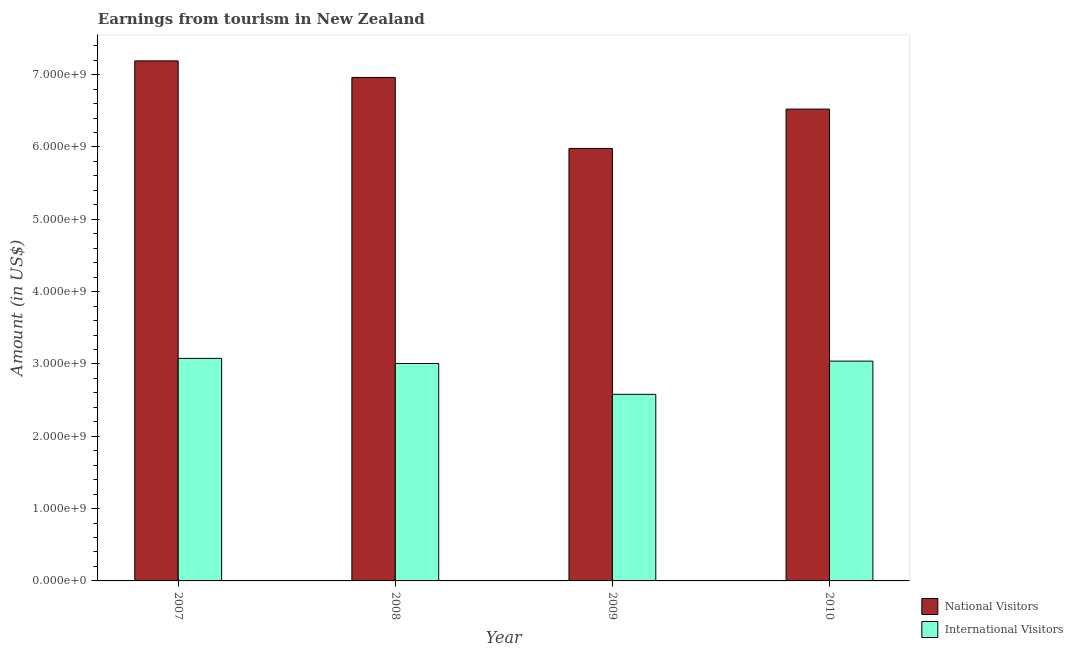How many different coloured bars are there?
Give a very brief answer. 2. Are the number of bars per tick equal to the number of legend labels?
Your answer should be very brief. Yes. How many bars are there on the 2nd tick from the left?
Keep it short and to the point. 2. How many bars are there on the 2nd tick from the right?
Your answer should be compact. 2. In how many cases, is the number of bars for a given year not equal to the number of legend labels?
Provide a short and direct response. 0. What is the amount earned from national visitors in 2010?
Ensure brevity in your answer.  6.52e+09. Across all years, what is the maximum amount earned from international visitors?
Your answer should be very brief. 3.08e+09. Across all years, what is the minimum amount earned from national visitors?
Your answer should be very brief. 5.98e+09. In which year was the amount earned from international visitors maximum?
Your answer should be very brief. 2007. What is the total amount earned from national visitors in the graph?
Keep it short and to the point. 2.67e+1. What is the difference between the amount earned from national visitors in 2008 and that in 2009?
Your answer should be very brief. 9.82e+08. What is the difference between the amount earned from national visitors in 2010 and the amount earned from international visitors in 2007?
Keep it short and to the point. -6.67e+08. What is the average amount earned from international visitors per year?
Make the answer very short. 2.93e+09. What is the ratio of the amount earned from international visitors in 2008 to that in 2010?
Make the answer very short. 0.99. Is the amount earned from international visitors in 2008 less than that in 2009?
Give a very brief answer. No. What is the difference between the highest and the second highest amount earned from international visitors?
Keep it short and to the point. 3.80e+07. What is the difference between the highest and the lowest amount earned from national visitors?
Provide a succinct answer. 1.21e+09. In how many years, is the amount earned from international visitors greater than the average amount earned from international visitors taken over all years?
Keep it short and to the point. 3. Is the sum of the amount earned from national visitors in 2008 and 2010 greater than the maximum amount earned from international visitors across all years?
Make the answer very short. Yes. What does the 2nd bar from the left in 2008 represents?
Your answer should be compact. International Visitors. What does the 2nd bar from the right in 2010 represents?
Offer a very short reply. National Visitors. How many bars are there?
Your answer should be very brief. 8. Are all the bars in the graph horizontal?
Provide a succinct answer. No. How many years are there in the graph?
Your answer should be very brief. 4. What is the difference between two consecutive major ticks on the Y-axis?
Offer a terse response. 1.00e+09. Does the graph contain any zero values?
Your response must be concise. No. Does the graph contain grids?
Give a very brief answer. No. How many legend labels are there?
Give a very brief answer. 2. What is the title of the graph?
Provide a short and direct response. Earnings from tourism in New Zealand. What is the label or title of the Y-axis?
Your answer should be compact. Amount (in US$). What is the Amount (in US$) of National Visitors in 2007?
Provide a short and direct response. 7.19e+09. What is the Amount (in US$) of International Visitors in 2007?
Provide a short and direct response. 3.08e+09. What is the Amount (in US$) of National Visitors in 2008?
Offer a very short reply. 6.96e+09. What is the Amount (in US$) in International Visitors in 2008?
Offer a very short reply. 3.01e+09. What is the Amount (in US$) of National Visitors in 2009?
Your answer should be compact. 5.98e+09. What is the Amount (in US$) in International Visitors in 2009?
Offer a terse response. 2.58e+09. What is the Amount (in US$) of National Visitors in 2010?
Make the answer very short. 6.52e+09. What is the Amount (in US$) of International Visitors in 2010?
Offer a very short reply. 3.04e+09. Across all years, what is the maximum Amount (in US$) of National Visitors?
Your answer should be very brief. 7.19e+09. Across all years, what is the maximum Amount (in US$) in International Visitors?
Provide a succinct answer. 3.08e+09. Across all years, what is the minimum Amount (in US$) of National Visitors?
Keep it short and to the point. 5.98e+09. Across all years, what is the minimum Amount (in US$) of International Visitors?
Your response must be concise. 2.58e+09. What is the total Amount (in US$) in National Visitors in the graph?
Your response must be concise. 2.67e+1. What is the total Amount (in US$) in International Visitors in the graph?
Offer a terse response. 1.17e+1. What is the difference between the Amount (in US$) in National Visitors in 2007 and that in 2008?
Your answer should be compact. 2.29e+08. What is the difference between the Amount (in US$) of International Visitors in 2007 and that in 2008?
Ensure brevity in your answer.  7.10e+07. What is the difference between the Amount (in US$) in National Visitors in 2007 and that in 2009?
Offer a terse response. 1.21e+09. What is the difference between the Amount (in US$) of International Visitors in 2007 and that in 2009?
Provide a succinct answer. 4.97e+08. What is the difference between the Amount (in US$) in National Visitors in 2007 and that in 2010?
Provide a succinct answer. 6.67e+08. What is the difference between the Amount (in US$) in International Visitors in 2007 and that in 2010?
Keep it short and to the point. 3.80e+07. What is the difference between the Amount (in US$) of National Visitors in 2008 and that in 2009?
Make the answer very short. 9.82e+08. What is the difference between the Amount (in US$) in International Visitors in 2008 and that in 2009?
Offer a very short reply. 4.26e+08. What is the difference between the Amount (in US$) in National Visitors in 2008 and that in 2010?
Offer a terse response. 4.38e+08. What is the difference between the Amount (in US$) of International Visitors in 2008 and that in 2010?
Your answer should be compact. -3.30e+07. What is the difference between the Amount (in US$) of National Visitors in 2009 and that in 2010?
Ensure brevity in your answer.  -5.44e+08. What is the difference between the Amount (in US$) in International Visitors in 2009 and that in 2010?
Make the answer very short. -4.59e+08. What is the difference between the Amount (in US$) of National Visitors in 2007 and the Amount (in US$) of International Visitors in 2008?
Offer a terse response. 4.18e+09. What is the difference between the Amount (in US$) of National Visitors in 2007 and the Amount (in US$) of International Visitors in 2009?
Your answer should be compact. 4.61e+09. What is the difference between the Amount (in US$) in National Visitors in 2007 and the Amount (in US$) in International Visitors in 2010?
Your answer should be compact. 4.15e+09. What is the difference between the Amount (in US$) in National Visitors in 2008 and the Amount (in US$) in International Visitors in 2009?
Ensure brevity in your answer.  4.38e+09. What is the difference between the Amount (in US$) in National Visitors in 2008 and the Amount (in US$) in International Visitors in 2010?
Provide a short and direct response. 3.92e+09. What is the difference between the Amount (in US$) of National Visitors in 2009 and the Amount (in US$) of International Visitors in 2010?
Your answer should be very brief. 2.94e+09. What is the average Amount (in US$) of National Visitors per year?
Offer a very short reply. 6.66e+09. What is the average Amount (in US$) in International Visitors per year?
Ensure brevity in your answer.  2.93e+09. In the year 2007, what is the difference between the Amount (in US$) of National Visitors and Amount (in US$) of International Visitors?
Offer a very short reply. 4.11e+09. In the year 2008, what is the difference between the Amount (in US$) of National Visitors and Amount (in US$) of International Visitors?
Offer a very short reply. 3.96e+09. In the year 2009, what is the difference between the Amount (in US$) of National Visitors and Amount (in US$) of International Visitors?
Ensure brevity in your answer.  3.40e+09. In the year 2010, what is the difference between the Amount (in US$) in National Visitors and Amount (in US$) in International Visitors?
Your answer should be very brief. 3.48e+09. What is the ratio of the Amount (in US$) in National Visitors in 2007 to that in 2008?
Your answer should be compact. 1.03. What is the ratio of the Amount (in US$) of International Visitors in 2007 to that in 2008?
Provide a succinct answer. 1.02. What is the ratio of the Amount (in US$) in National Visitors in 2007 to that in 2009?
Your answer should be compact. 1.2. What is the ratio of the Amount (in US$) of International Visitors in 2007 to that in 2009?
Keep it short and to the point. 1.19. What is the ratio of the Amount (in US$) in National Visitors in 2007 to that in 2010?
Provide a short and direct response. 1.1. What is the ratio of the Amount (in US$) in International Visitors in 2007 to that in 2010?
Your answer should be compact. 1.01. What is the ratio of the Amount (in US$) of National Visitors in 2008 to that in 2009?
Offer a terse response. 1.16. What is the ratio of the Amount (in US$) in International Visitors in 2008 to that in 2009?
Provide a short and direct response. 1.17. What is the ratio of the Amount (in US$) in National Visitors in 2008 to that in 2010?
Give a very brief answer. 1.07. What is the ratio of the Amount (in US$) in National Visitors in 2009 to that in 2010?
Provide a short and direct response. 0.92. What is the ratio of the Amount (in US$) in International Visitors in 2009 to that in 2010?
Make the answer very short. 0.85. What is the difference between the highest and the second highest Amount (in US$) of National Visitors?
Your response must be concise. 2.29e+08. What is the difference between the highest and the second highest Amount (in US$) of International Visitors?
Offer a terse response. 3.80e+07. What is the difference between the highest and the lowest Amount (in US$) in National Visitors?
Your answer should be compact. 1.21e+09. What is the difference between the highest and the lowest Amount (in US$) in International Visitors?
Your answer should be compact. 4.97e+08. 